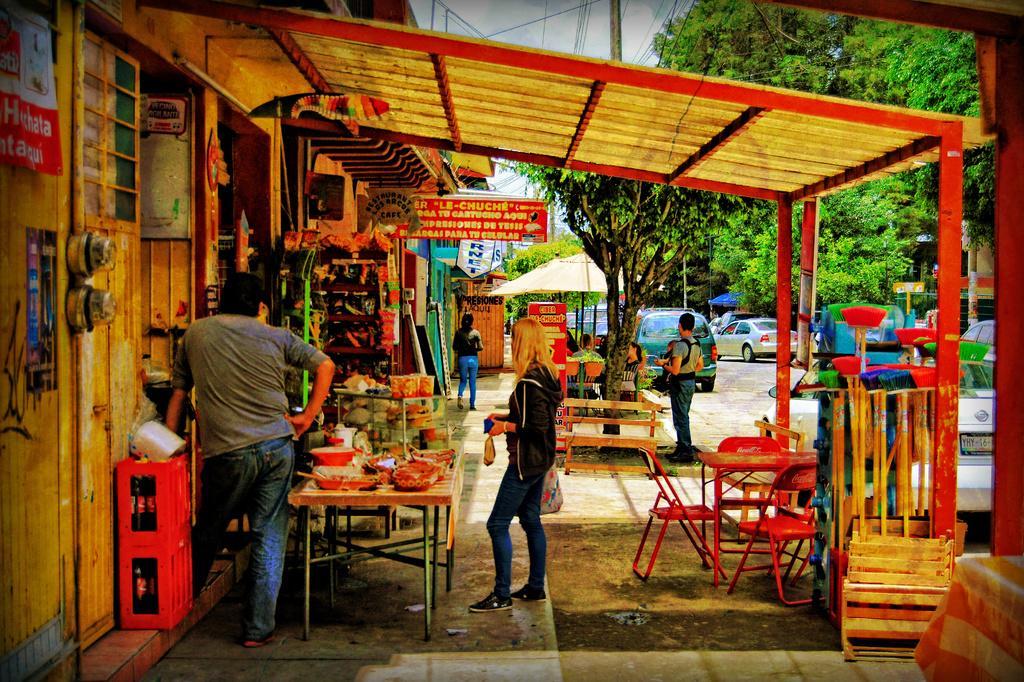Can you describe this image briefly? In this image I see few persons and I see chairs, tables and few things over here and I see few stalls. In the background Iseecars and the trees. 